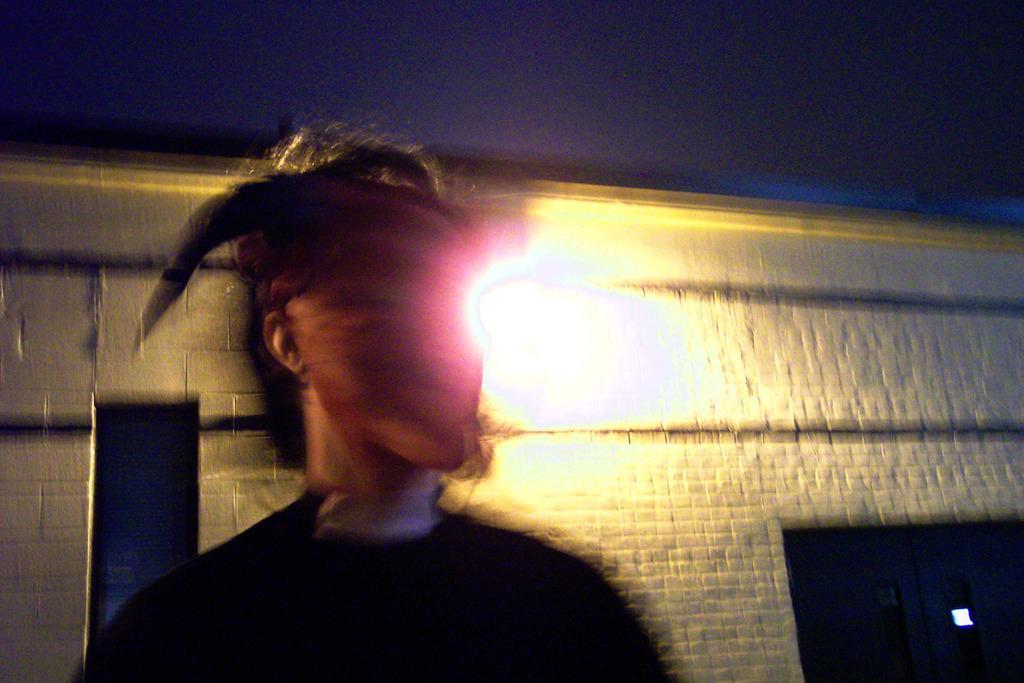How would you summarize this image in a sentence or two? In this picture there is a person and we can see building and light. In the background of the image we can see the sky. 